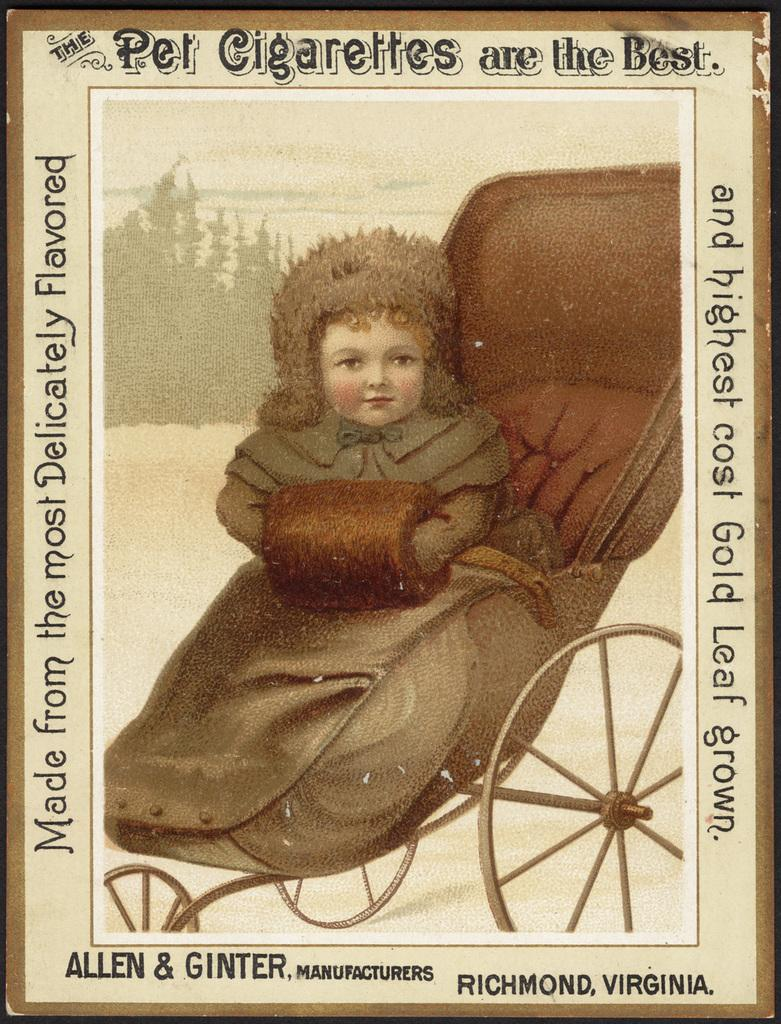What is the main subject of the image? The main subject of the image is a frame. What can be seen inside the frame? A girl is sitting on a cart within the frame. Is the girl experiencing a river ride in the image? There is no indication of a river or a river ride in the image. The girl is sitting on a cart within the frame, but the context of the ride is not specified. 